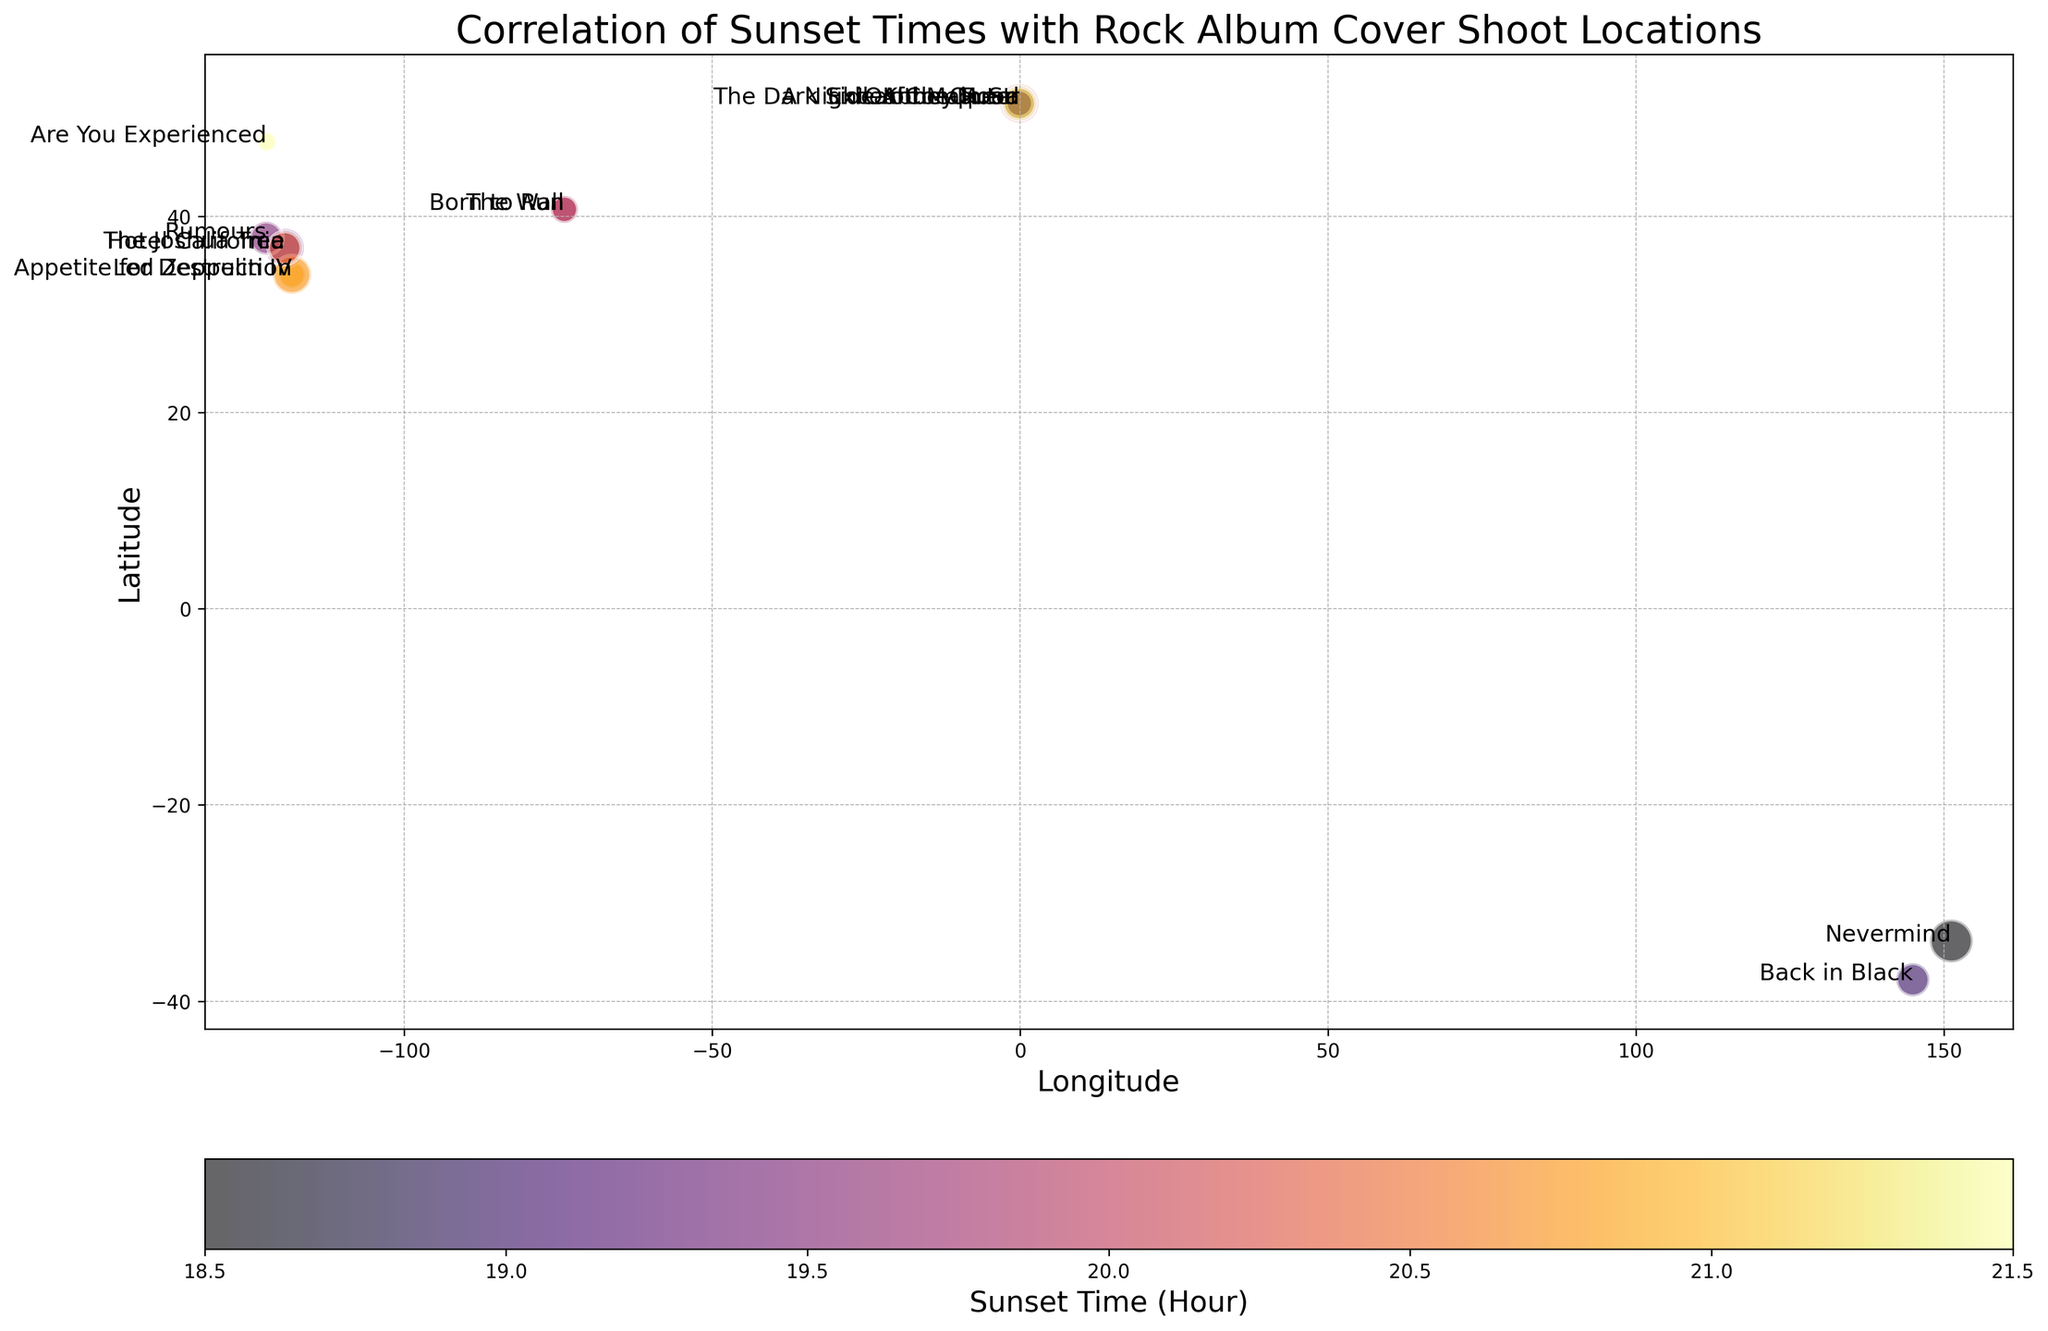Which album cover was shot at the location with the latest sunset time? Look at the color bar indicating sunset times and find the deepest color (which corresponds to the latest time) on the chart. The deepest color (dark red) corresponds to "Are You Experienced" with a sunset time of 21:30.
Answer: Are You Experienced Which album locations are at a latitude higher than 50 degrees? Check the y-axis for latitudes greater than 50 degrees and see which album names are annotated there. The albums with higher latitudes are "Abbey Road," "The Dark Side of the Moon," "A Night at the Opera," "Exile on Main St.," and "OK Computer."
Answer: Abbey Road, The Dark Side of the Moon, A Night at the Opera, Exile on Main St., OK Computer How many albums were shot at locations with a sunset time earlier than 19:00? Look at the color bar indicating sunset times and find the visual regions representing times earlier than 19:00. There are two albums ("Nevermind" at 18:30 and "A Night at the Opera" at 18:45).
Answer: 2 What is the total number of albums released between 1975 and 1980 inclusive? Identify and count the bubbles for albums with release years between 1975 and 1980. "The Wall" (2 albums), "A Night at the Opera" (3 albums), "Hotel California" (4 albums), "Rumours" (3 albums), and "Back in Black" (3 albums). Total is 2 + 3 + 4 + 3 + 3 = 15.
Answer: 15 Do more albums have sunset times of 20:00 or later compared to before 20:00? Count the number of bubbles annotated with sunset times of 20:00 or later and compare it to the count for times before 20:00. Albums with sunset time 20:00 or later: "The Dark Side of the Moon" (4), "Led Zeppelin IV" (2), "The Wall" (2), "Appetite for Destruction" (4), "The Joshua Tree" (3), "OK Computer" (3), "Are You Experienced" (1). Total is 19 albums. Before 20:00: 3 + 3 + 4 + 1 + 3 + 2 + 3 = 19 albums.
Answer: No, equal Which album has the farthest west longitude and what is its corresponding sunset time and number of albums? Look at the x-axis for the farthest left point and identify the album annotated there. "Rumours" at longitude -122.419418 with sunset time 19:30 and 3 albums.
Answer: Rumours, 19:30, 3 What is the difference in sunset times between "Hotel California" and "Nevermind"? Find the sunset times from the color bar and annotations. "Hotel California" at 19:15 and "Nevermind" at 18:30. The difference is 19:15 - 18:30 = 45 minutes.
Answer: 45 minutes Which album annotations are clustered near latitude 51 and what common characteristic do they share? Identify annotations clustered near the latitude 51 region. "Abbey Road," "The Dark Side of the Moon," "A Night at the Opera," "Exile on Main St.," and "OK Computer," all have London as a common geographic location.
Answer: Abbey Road, The Dark Side of the Moon, A Night at the Opera, Exile on Main St., OK Computer; London location How many albums are released before 1980 and have sunset times later than 20:00? Count bubbles for albums released before 1980 with darker colors on the color bar corresponding to times later than 20:00. "Led Zeppelin IV" (2), "The Dark Side of the Moon" (4), "Are You Experienced" (1). Total is 2 + 4 + 1 = 7.
Answer: 7 Which albums have longitude values between -120 and -100 and how many albums are represented in this range? Find the bubbles placed within the longitude values -120 to -100. Only "Hotel California" at -119.417931 and "The Joshua Tree" at -119.417931 with 4 and 3 albums respectively. Total is 4 + 3 = 7 albums.
Answer: Hotel California, The Joshua Tree; 7 albums 